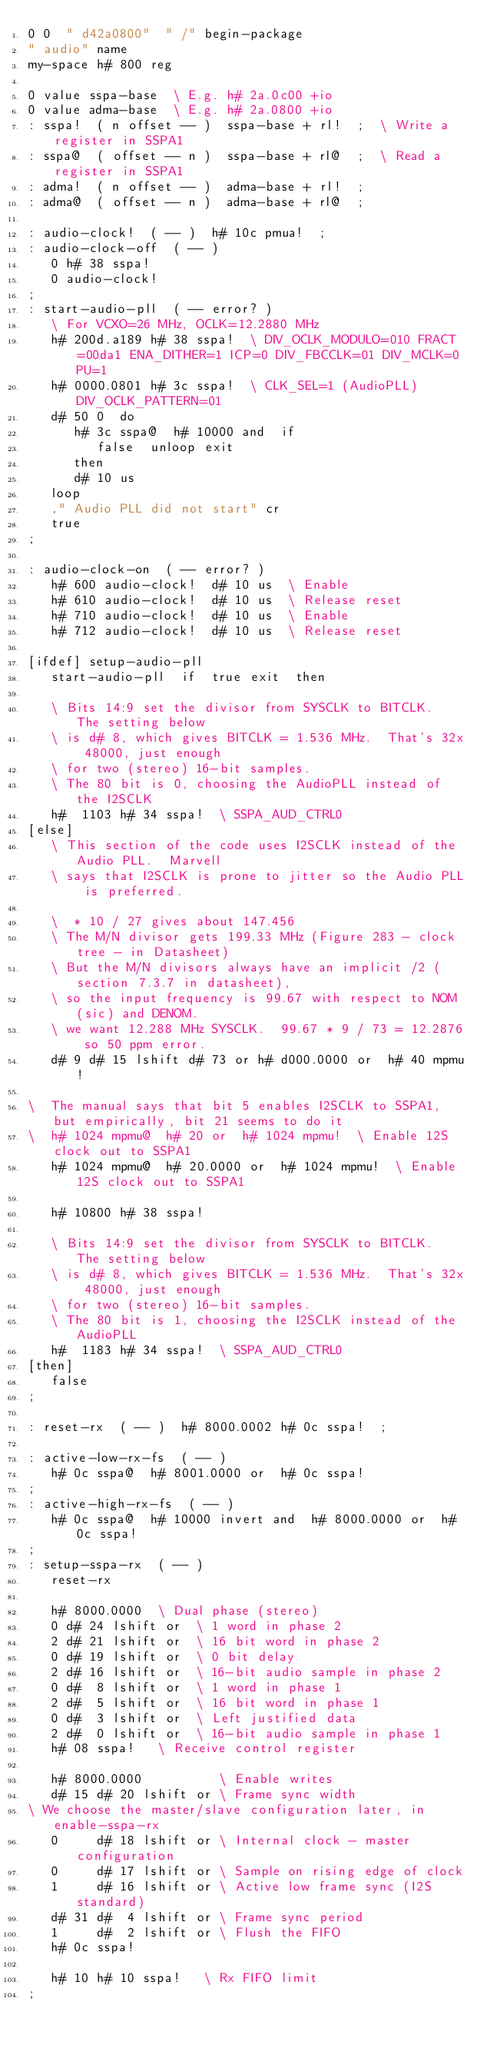Convert code to text. <code><loc_0><loc_0><loc_500><loc_500><_Forth_>0 0  " d42a0800"  " /" begin-package
" audio" name
my-space h# 800 reg

0 value sspa-base  \ E.g. h# 2a.0c00 +io
0 value adma-base  \ E.g. h# 2a.0800 +io
: sspa!  ( n offset -- )  sspa-base + rl!  ;  \ Write a register in SSPA1
: sspa@  ( offset -- n )  sspa-base + rl@  ;  \ Read a register in SSPA1
: adma!  ( n offset -- )  adma-base + rl!  ;
: adma@  ( offset -- n )  adma-base + rl@  ;

: audio-clock!  ( -- )  h# 10c pmua!  ;
: audio-clock-off  ( -- )
   0 h# 38 sspa!
   0 audio-clock!
;
: start-audio-pll  ( -- error? )
   \ For VCXO=26 MHz, OCLK=12.2880 MHz
   h# 200d.a189 h# 38 sspa!  \ DIV_OCLK_MODULO=010 FRACT=00da1 ENA_DITHER=1 ICP=0 DIV_FBCCLK=01 DIV_MCLK=0 PU=1
   h# 0000.0801 h# 3c sspa!  \ CLK_SEL=1 (AudioPLL) DIV_OCLK_PATTERN=01
   d# 50 0  do
      h# 3c sspa@  h# 10000 and  if
         false  unloop exit
      then
      d# 10 us
   loop
   ." Audio PLL did not start" cr
   true
;

: audio-clock-on  ( -- error? )
   h# 600 audio-clock!  d# 10 us  \ Enable
   h# 610 audio-clock!  d# 10 us  \ Release reset
   h# 710 audio-clock!  d# 10 us  \ Enable
   h# 712 audio-clock!  d# 10 us  \ Release reset

[ifdef] setup-audio-pll
   start-audio-pll  if  true exit  then

   \ Bits 14:9 set the divisor from SYSCLK to BITCLK.  The setting below
   \ is d# 8, which gives BITCLK = 1.536 MHz.  That's 32x 48000, just enough
   \ for two (stereo) 16-bit samples.
   \ The 80 bit is 0, choosing the AudioPLL instead of the I2SCLK
   h#  1103 h# 34 sspa!  \ SSPA_AUD_CTRL0
[else]
   \ This section of the code uses I2SCLK instead of the Audio PLL.  Marvell
   \ says that I2SCLK is prone to jitter so the Audio PLL is preferred.

   \  * 10 / 27 gives about 147.456
   \ The M/N divisor gets 199.33 MHz (Figure 283 - clock tree - in Datasheet)
   \ But the M/N divisors always have an implicit /2 (section 7.3.7 in datasheet),
   \ so the input frequency is 99.67 with respect to NOM (sic) and DENOM.
   \ we want 12.288 MHz SYSCLK.  99.67 * 9 / 73 = 12.2876 so 50 ppm error.
   d# 9 d# 15 lshift d# 73 or h# d000.0000 or  h# 40 mpmu!

\  The manual says that bit 5 enables I2SCLK to SSPA1, but empirically, bit 21 seems to do it
\  h# 1024 mpmu@  h# 20 or  h# 1024 mpmu!  \ Enable 12S clock out to SSPA1
   h# 1024 mpmu@  h# 20.0000 or  h# 1024 mpmu!  \ Enable 12S clock out to SSPA1

   h# 10800 h# 38 sspa!

   \ Bits 14:9 set the divisor from SYSCLK to BITCLK.  The setting below
   \ is d# 8, which gives BITCLK = 1.536 MHz.  That's 32x 48000, just enough
   \ for two (stereo) 16-bit samples.
   \ The 80 bit is 1, choosing the I2SCLK instead of the AudioPLL
   h#  1183 h# 34 sspa!  \ SSPA_AUD_CTRL0
[then]
   false
;

: reset-rx  ( -- )  h# 8000.0002 h# 0c sspa!  ;

: active-low-rx-fs  ( -- ) 
   h# 0c sspa@  h# 8001.0000 or  h# 0c sspa!
;
: active-high-rx-fs  ( -- ) 
   h# 0c sspa@  h# 10000 invert and  h# 8000.0000 or  h# 0c sspa!
;
: setup-sspa-rx  ( -- )
   reset-rx

   h# 8000.0000  \ Dual phase (stereo)
   0 d# 24 lshift or  \ 1 word in phase 2
   2 d# 21 lshift or  \ 16 bit word in phase 2
   0 d# 19 lshift or  \ 0 bit delay
   2 d# 16 lshift or  \ 16-bit audio sample in phase 2
   0 d#  8 lshift or  \ 1 word in phase 1
   2 d#  5 lshift or  \ 16 bit word in phase 1
   0 d#  3 lshift or  \ Left justified data
   2 d#  0 lshift or  \ 16-bit audio sample in phase 1
   h# 08 sspa!   \ Receive control register

   h# 8000.0000          \ Enable writes
   d# 15 d# 20 lshift or \ Frame sync width
\ We choose the master/slave configuration later, in enable-sspa-rx
   0     d# 18 lshift or \ Internal clock - master configuration
   0     d# 17 lshift or \ Sample on rising edge of clock
   1     d# 16 lshift or \ Active low frame sync (I2S standard)
   d# 31 d#  4 lshift or \ Frame sync period
   1     d#  2 lshift or \ Flush the FIFO
   h# 0c sspa!

   h# 10 h# 10 sspa!   \ Rx FIFO limit
;</code> 